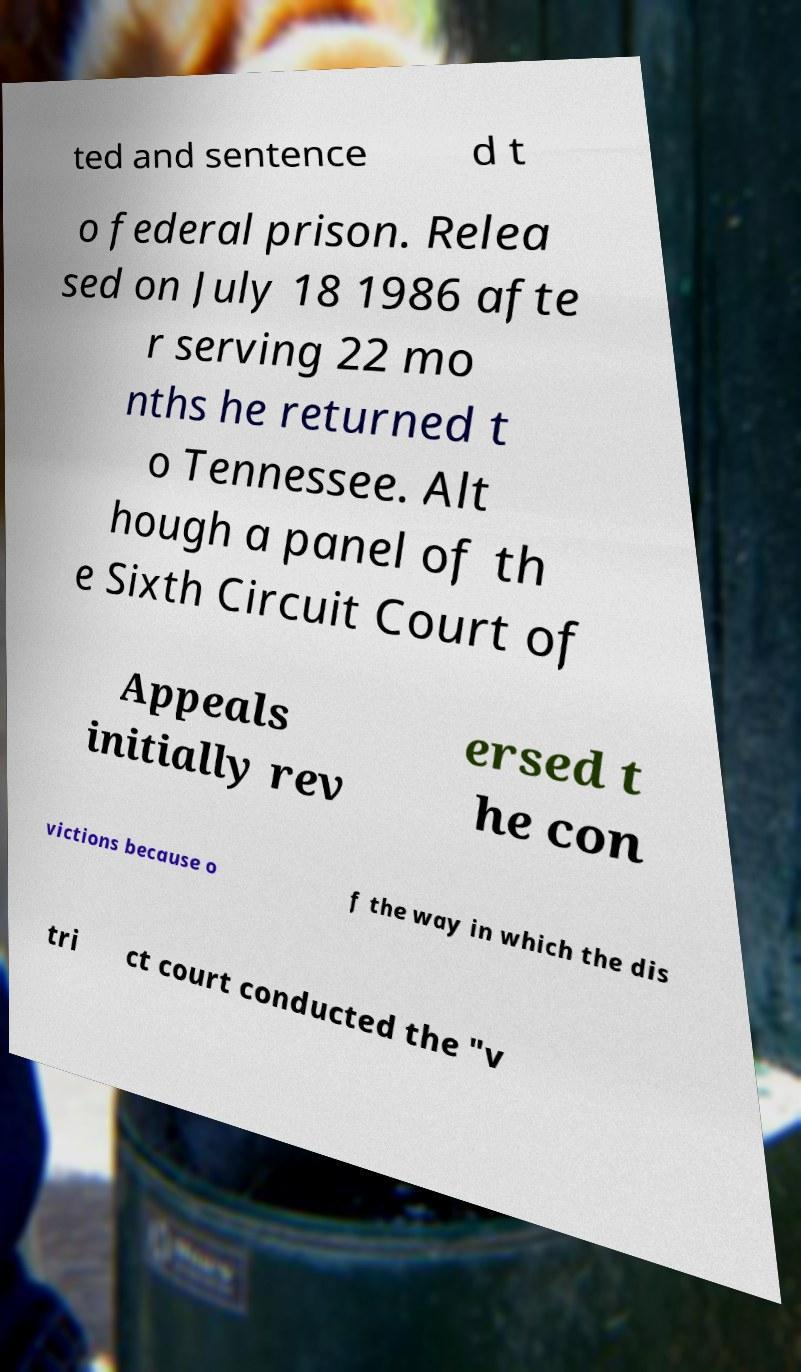Could you assist in decoding the text presented in this image and type it out clearly? ted and sentence d t o federal prison. Relea sed on July 18 1986 afte r serving 22 mo nths he returned t o Tennessee. Alt hough a panel of th e Sixth Circuit Court of Appeals initially rev ersed t he con victions because o f the way in which the dis tri ct court conducted the "v 